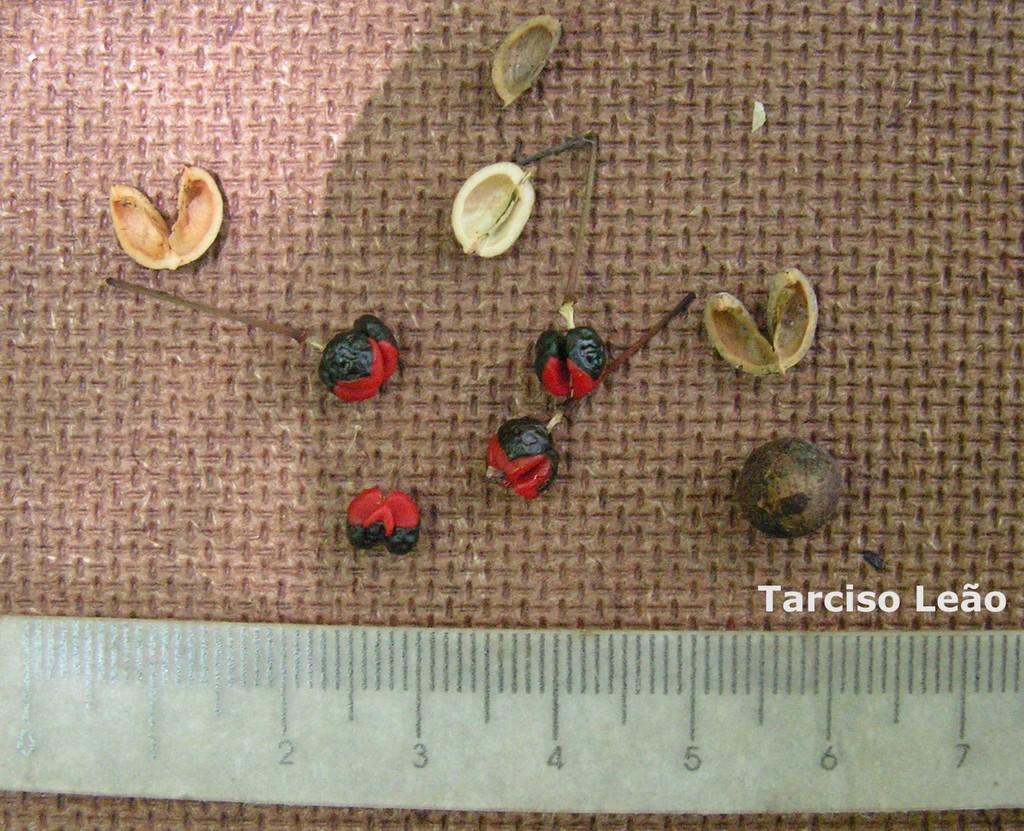Who took this photo?
Give a very brief answer. Tarciso leao. How far does the measurements go up?
Keep it short and to the point. 7. 